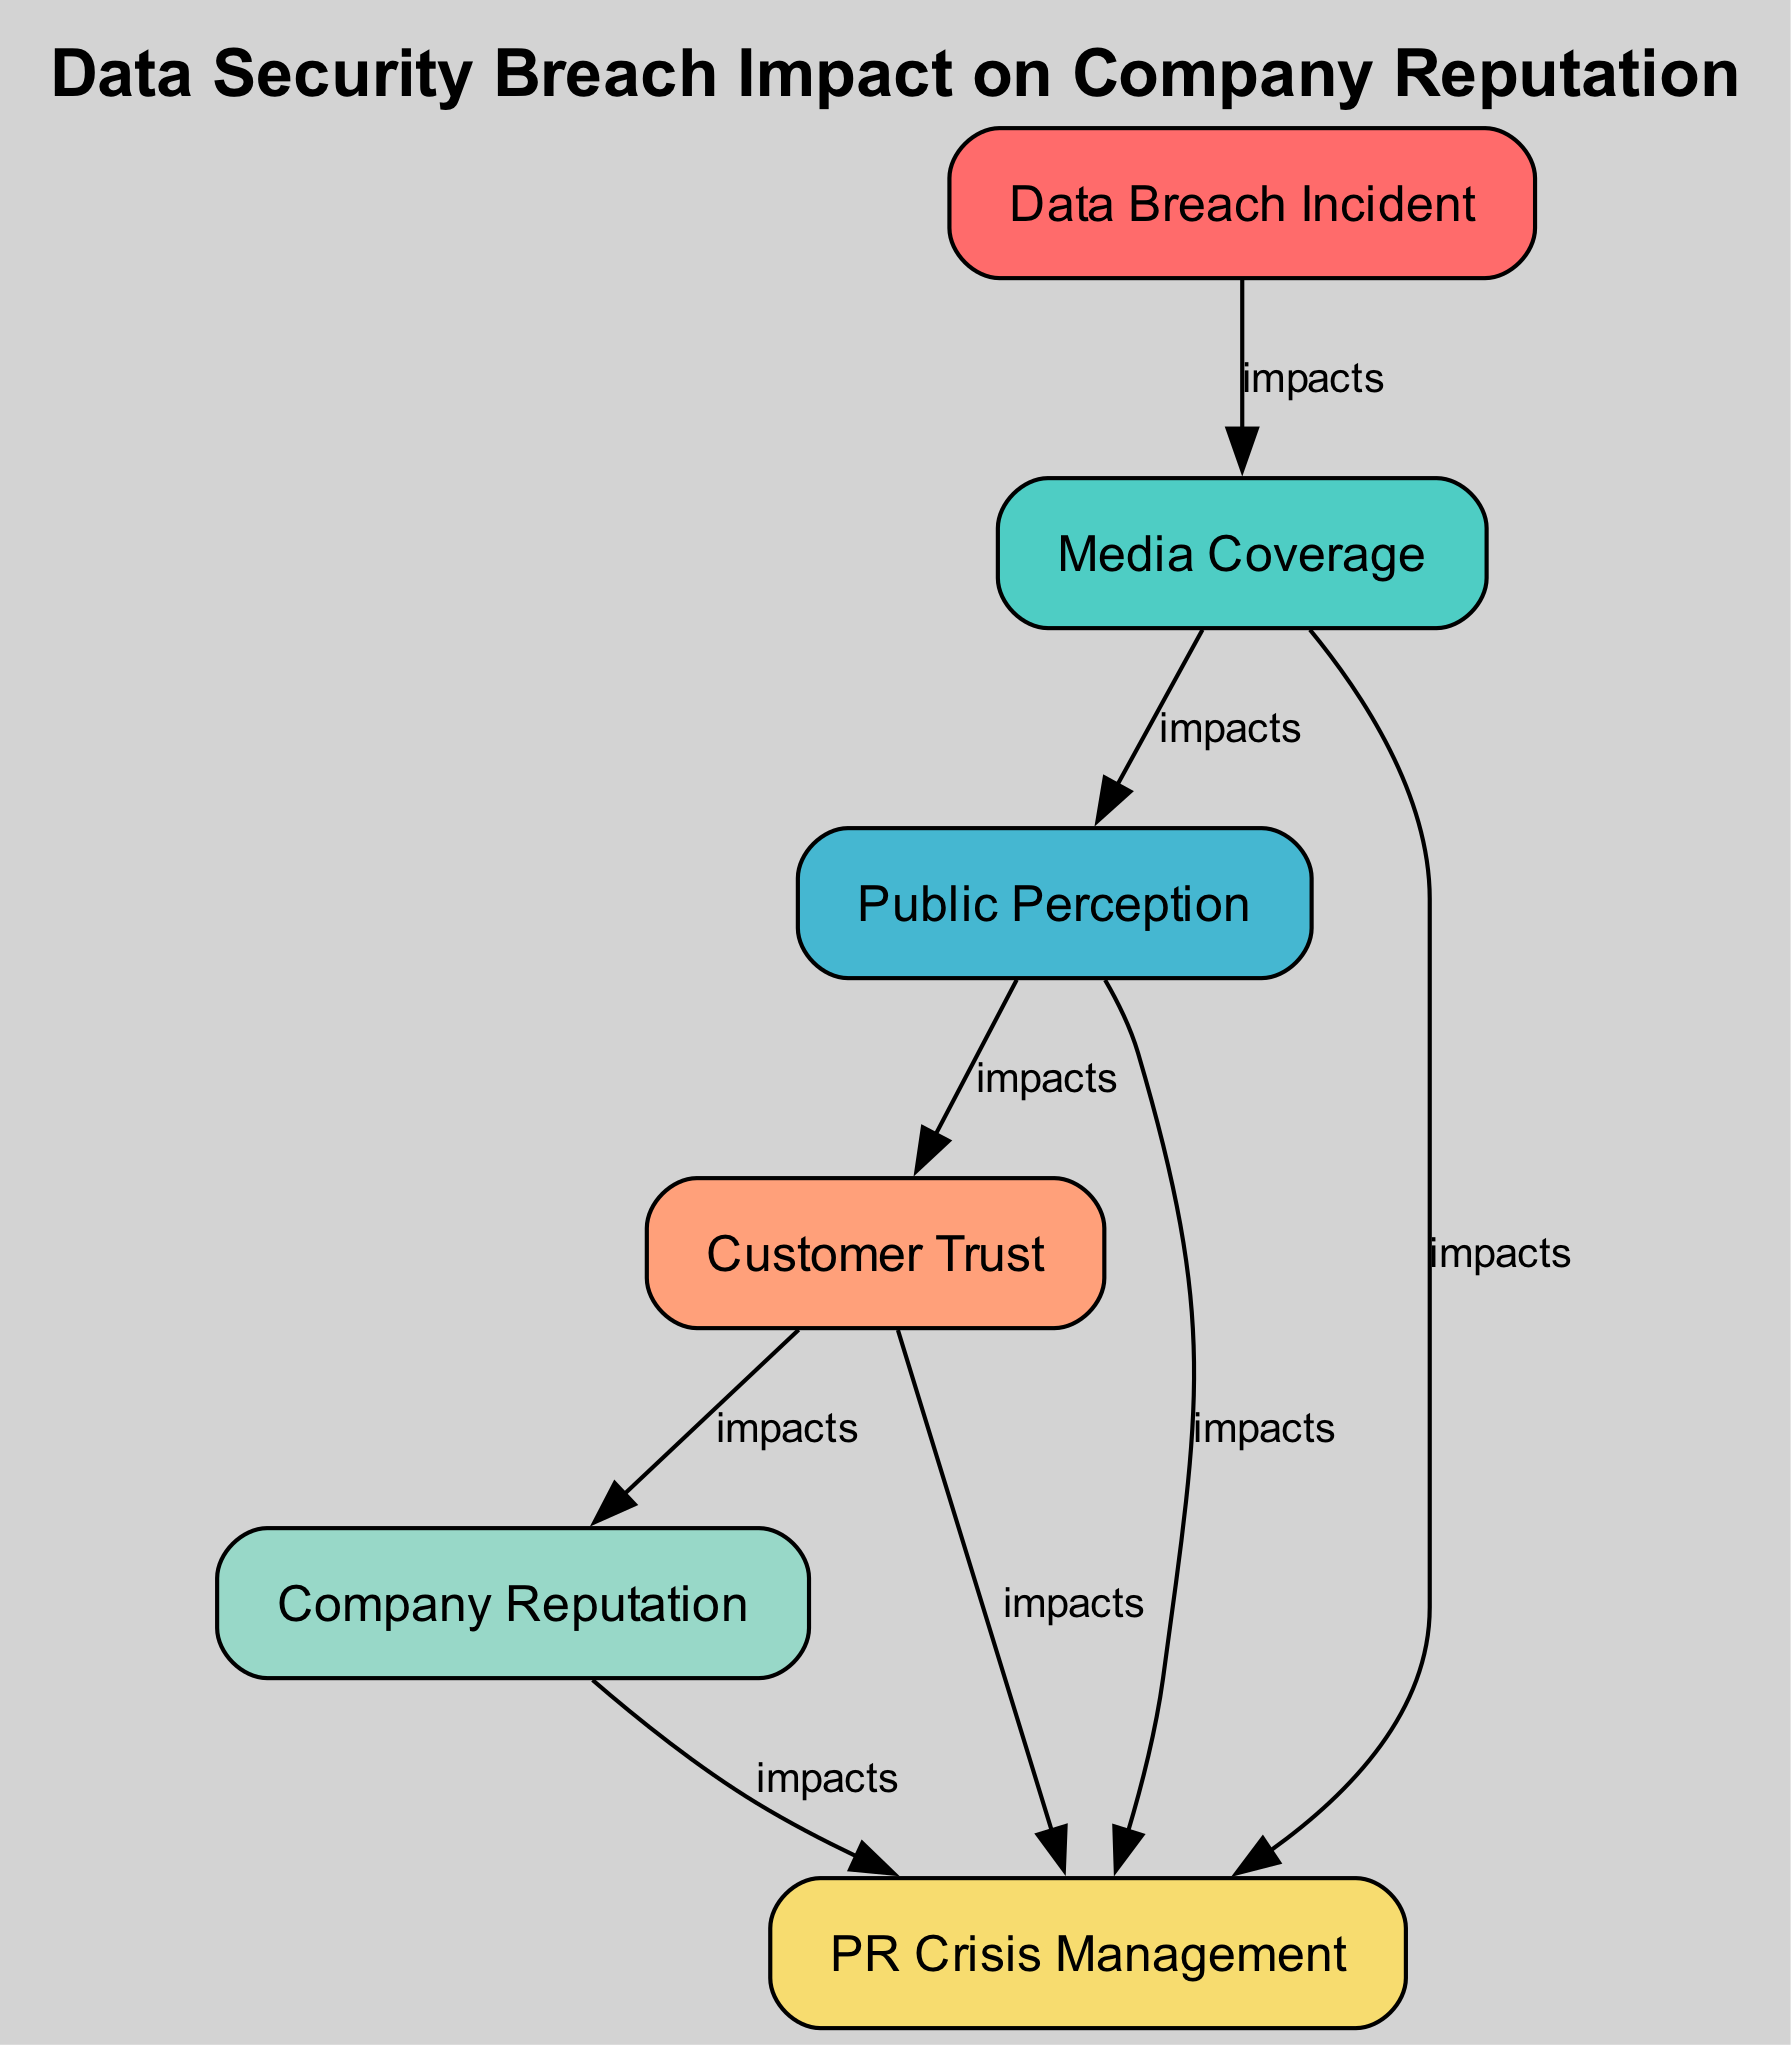What is the first node in the diagram? The first node is "Data Breach Incident," as it has no consuming relationships from other nodes, indicating it initiates the process.
Answer: Data Breach Incident How many nodes are in the diagram? By counting the elements listed in the data, there are six unique nodes: Data Breach Incident, Media Coverage, Public Perception, Customer Trust, Company Reputation, and PR Crisis Management.
Answer: Six What impacts the Public Perception? The only node that impacts Public Perception is Media Coverage, as indicated by the consuming relationship of Public Perception consuming Media Coverage.
Answer: Media Coverage Which node is ultimately affected by Customer Trust? The node that is ultimately affected by Customer Trust is Company Reputation, as it is the one that consumes Customer Trust in the flow of the diagram.
Answer: Company Reputation How many edges are in the diagram? To find the total number of edges, we can count the directed connections in the diagram. There are five connections from the nodes based on their consuming relationships.
Answer: Five What directly consumes Media Coverage? There is one node that directly consumes Media Coverage, which is Public Perception, as indicated in the diagram where Public Perception consumes Media Coverage.
Answer: Public Perception Which node is the most affected in the chain? The most affected node in this chain is Company Reputation, as it is at the end of the flow and is influenced by the other nodes.
Answer: Company Reputation What does PR Crisis Management consume? PR Crisis Management consumes four nodes: Media Coverage, Public Perception, Customer Trust, and Company Reputation, rising from multiple flows in the diagram.
Answer: Media Coverage, Public Perception, Customer Trust, Company Reputation Which node acts as the starting point for the security breach impact? The starting point for this security breach impact is the Data Breach Incident, as it triggers the entire sequence shown in the diagram.
Answer: Data Breach Incident 